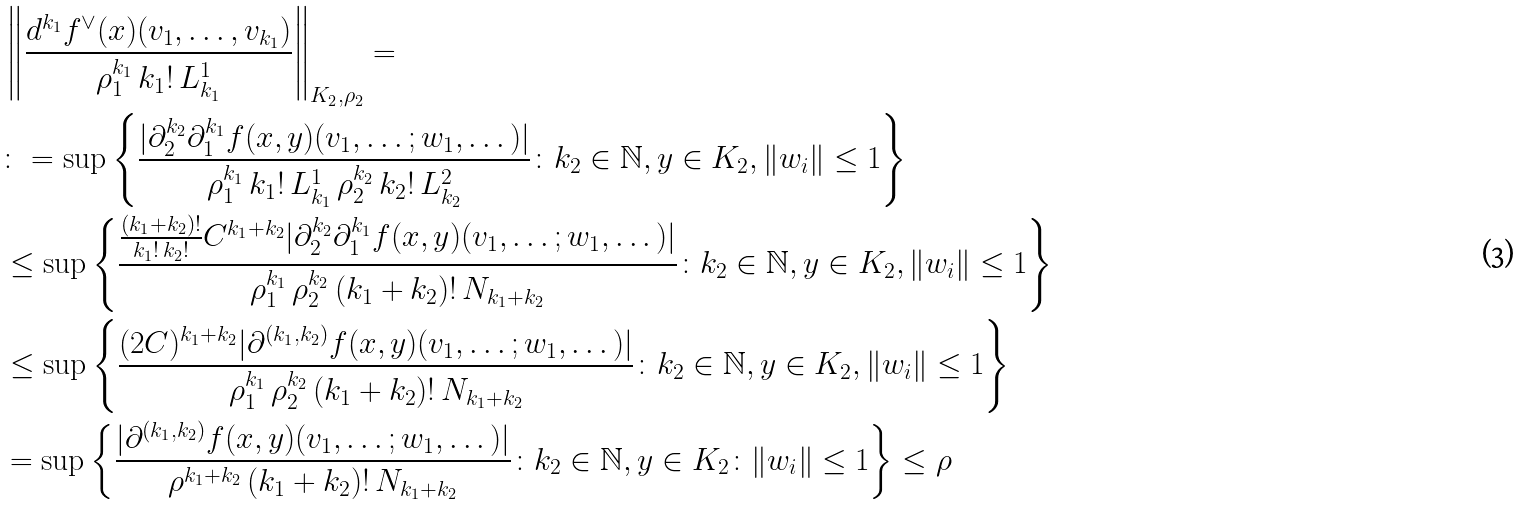<formula> <loc_0><loc_0><loc_500><loc_500>& \left \| \frac { d ^ { k _ { 1 } } f ^ { \vee } ( x ) ( v _ { 1 } , \dots , v _ { k _ { 1 } } ) } { \rho _ { 1 } ^ { k _ { 1 } } \, k _ { 1 } ! \, L ^ { 1 } _ { k _ { 1 } } } \right \| _ { K _ { 2 } , \rho _ { 2 } } = \\ & \colon = \sup \left \{ \frac { | \partial _ { 2 } ^ { k _ { 2 } } \partial _ { 1 } ^ { k _ { 1 } } f ( x , y ) ( v _ { 1 } , \dots ; w _ { 1 } , \dots ) | } { \rho _ { 1 } ^ { k _ { 1 } } \, k _ { 1 } ! \, L ^ { 1 } _ { k _ { 1 } } \, \rho _ { 2 } ^ { k _ { 2 } } \, k _ { 2 } ! \, L ^ { 2 } _ { k _ { 2 } } } \colon k _ { 2 } \in \mathbb { N } , y \in K _ { 2 } , \| w _ { i } \| \leq 1 \right \} \\ & \leq \sup \left \{ \frac { \frac { ( k _ { 1 } + k _ { 2 } ) ! } { k _ { 1 } ! \, k _ { 2 } ! } C ^ { k _ { 1 } + k _ { 2 } } | \partial _ { 2 } ^ { k _ { 2 } } \partial _ { 1 } ^ { k _ { 1 } } f ( x , y ) ( v _ { 1 } , \dots ; w _ { 1 } , \dots ) | } { \rho _ { 1 } ^ { k _ { 1 } } \, \rho _ { 2 } ^ { k _ { 2 } } \, ( k _ { 1 } + k _ { 2 } ) ! \, N _ { k _ { 1 } + k _ { 2 } } } \colon k _ { 2 } \in \mathbb { N } , y \in K _ { 2 } , \| w _ { i } \| \leq 1 \right \} \\ & \leq \sup \left \{ \frac { ( 2 C ) ^ { k _ { 1 } + k _ { 2 } } | \partial ^ { ( k _ { 1 } , k _ { 2 } ) } f ( x , y ) ( v _ { 1 } , \dots ; w _ { 1 } , \dots ) | } { \rho _ { 1 } ^ { k _ { 1 } } \, \rho _ { 2 } ^ { k _ { 2 } } \, ( k _ { 1 } + k _ { 2 } ) ! \, N _ { k _ { 1 } + k _ { 2 } } } \colon k _ { 2 } \in \mathbb { N } , y \in K _ { 2 } , \| w _ { i } \| \leq 1 \right \} \\ & = \sup \left \{ \frac { | \partial ^ { ( k _ { 1 } , k _ { 2 } ) } f ( x , y ) ( v _ { 1 } , \dots ; w _ { 1 } , \dots ) | } { \rho ^ { k _ { 1 } + k _ { 2 } } \, ( k _ { 1 } + k _ { 2 } ) ! \, N _ { k _ { 1 } + k _ { 2 } } } \colon k _ { 2 } \in \mathbb { N } , y \in K _ { 2 } \colon \| w _ { i } \| \leq 1 \right \} \leq \rho</formula> 